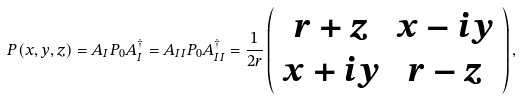Convert formula to latex. <formula><loc_0><loc_0><loc_500><loc_500>P ( x , y , z ) = A _ { I } P _ { 0 } A _ { I } ^ { \dagger } = A _ { I I } P _ { 0 } A _ { I I } ^ { \dagger } = \frac { 1 } { 2 r } \left ( \begin{array} { c c } r + z & x - i y \\ x + i y & r - z \end{array} \right ) ,</formula> 